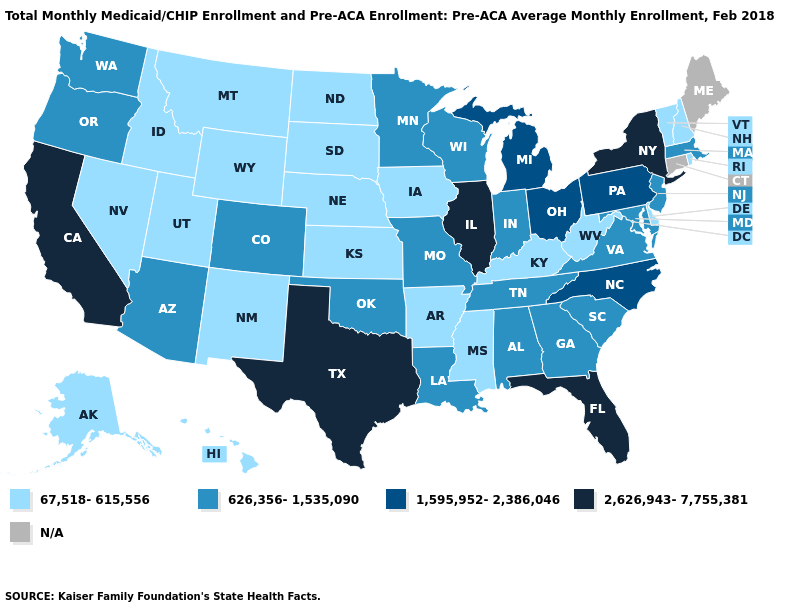Does Oregon have the lowest value in the West?
Write a very short answer. No. Which states have the lowest value in the MidWest?
Quick response, please. Iowa, Kansas, Nebraska, North Dakota, South Dakota. Name the states that have a value in the range N/A?
Quick response, please. Connecticut, Maine. What is the value of Virginia?
Keep it brief. 626,356-1,535,090. Name the states that have a value in the range 626,356-1,535,090?
Answer briefly. Alabama, Arizona, Colorado, Georgia, Indiana, Louisiana, Maryland, Massachusetts, Minnesota, Missouri, New Jersey, Oklahoma, Oregon, South Carolina, Tennessee, Virginia, Washington, Wisconsin. What is the lowest value in the USA?
Be succinct. 67,518-615,556. Does the first symbol in the legend represent the smallest category?
Write a very short answer. Yes. Among the states that border California , does Nevada have the lowest value?
Keep it brief. Yes. Which states have the highest value in the USA?
Write a very short answer. California, Florida, Illinois, New York, Texas. Among the states that border Nebraska , does Colorado have the lowest value?
Answer briefly. No. Does New York have the highest value in the Northeast?
Concise answer only. Yes. What is the value of Michigan?
Write a very short answer. 1,595,952-2,386,046. Name the states that have a value in the range 67,518-615,556?
Keep it brief. Alaska, Arkansas, Delaware, Hawaii, Idaho, Iowa, Kansas, Kentucky, Mississippi, Montana, Nebraska, Nevada, New Hampshire, New Mexico, North Dakota, Rhode Island, South Dakota, Utah, Vermont, West Virginia, Wyoming. Name the states that have a value in the range 626,356-1,535,090?
Keep it brief. Alabama, Arizona, Colorado, Georgia, Indiana, Louisiana, Maryland, Massachusetts, Minnesota, Missouri, New Jersey, Oklahoma, Oregon, South Carolina, Tennessee, Virginia, Washington, Wisconsin. 